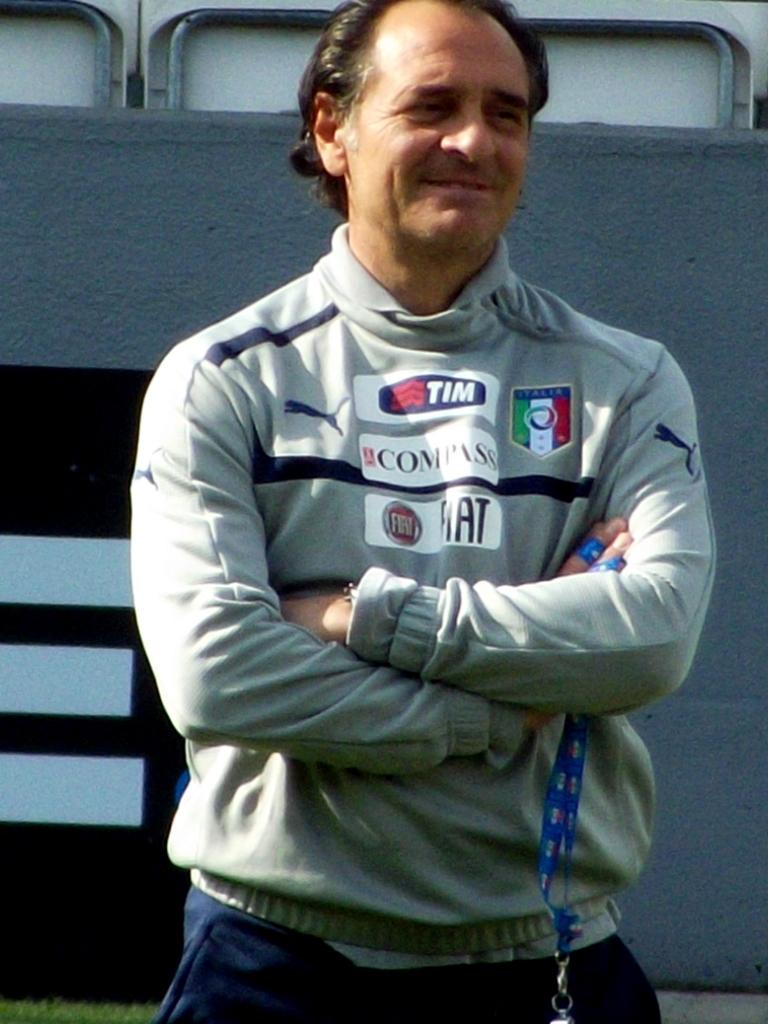<image>
Render a clear and concise summary of the photo. A man stands with his arms folded wearing a grey sweater that has stickers that say Tim, Compass and Fiat on them. 